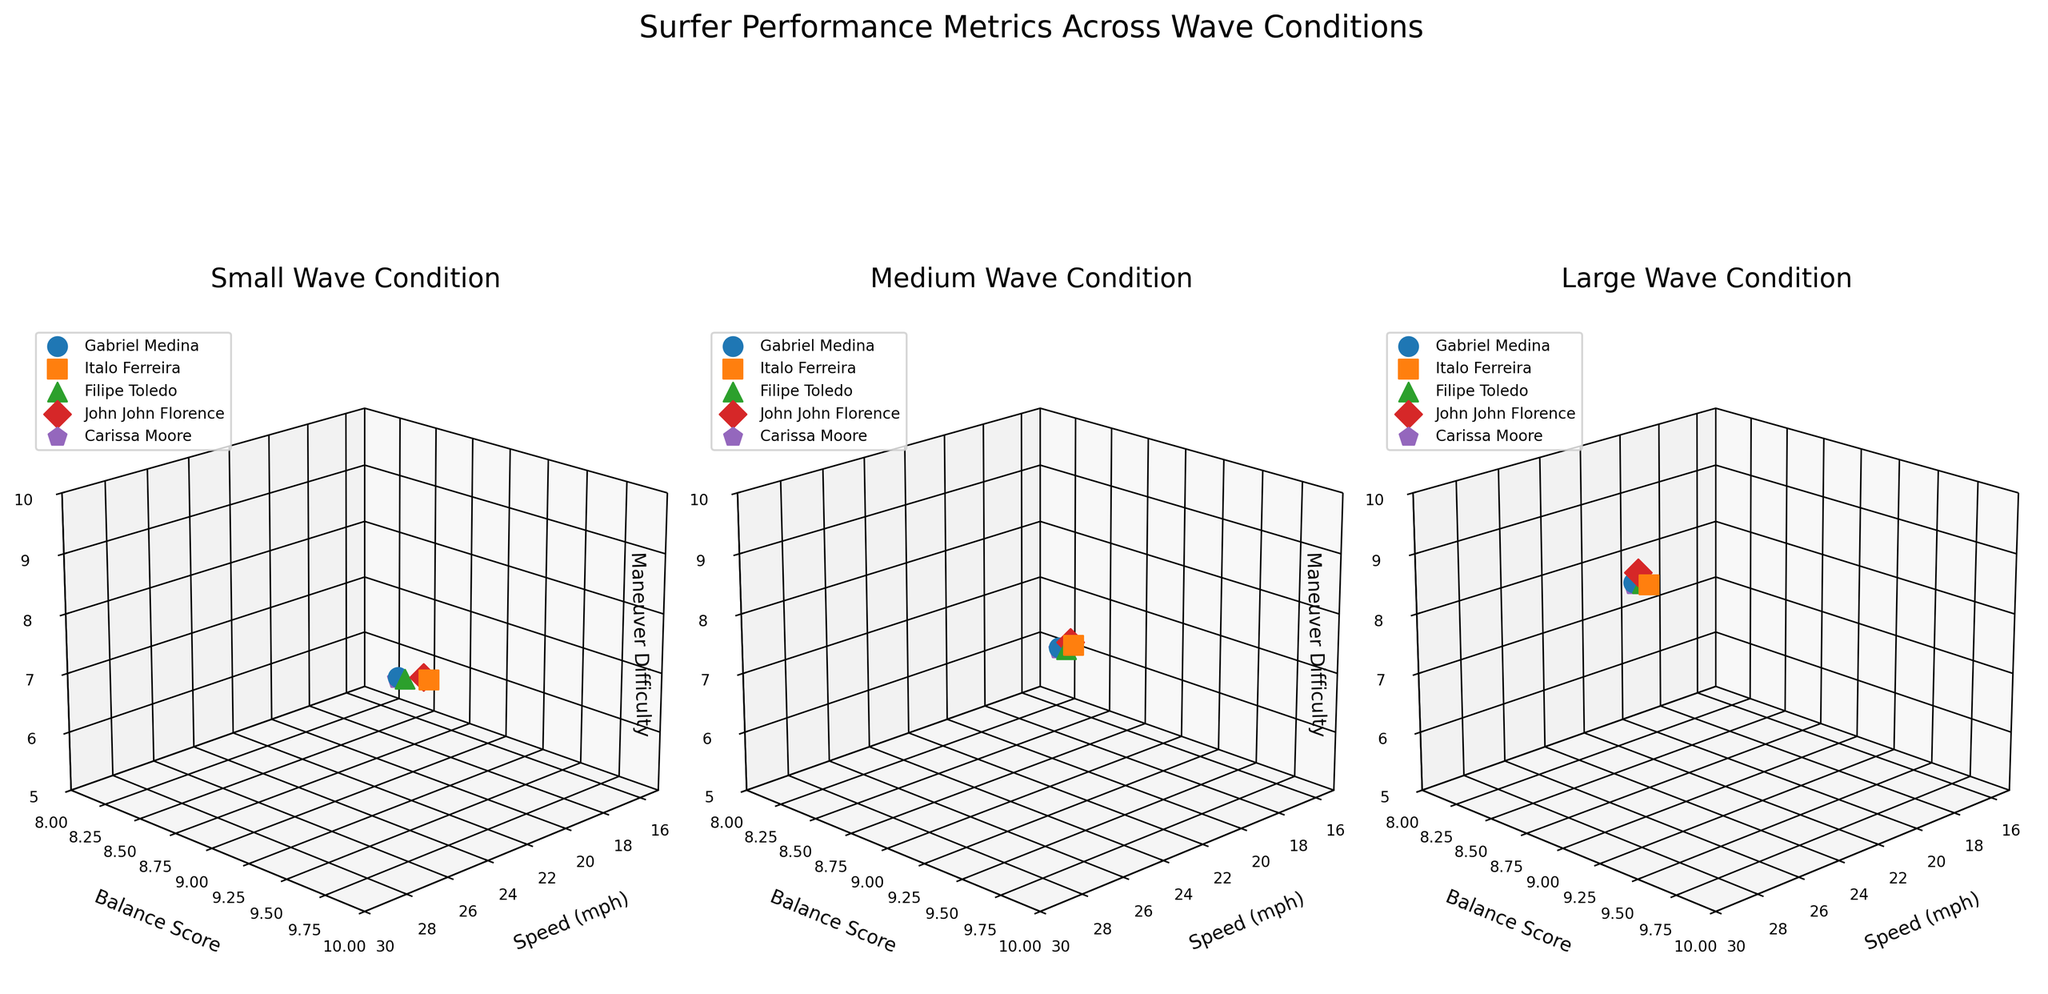How many surfers are plotted in each subplot? Each subplot represents a different wave condition (Small, Medium, Large), and each surfer is marked with a unique marker and color. By counting the different markers and colors in any subplot, we can see there are five surfers plotted in each.
Answer: 5 Which wave condition had the highest maneuver difficulty for Carissa Moore? By looking at the points representing Carissa Moore in the subplots (each subplot corresponds to a wave condition), we can see the highest 'Maneuver Difficulty' score associated with her name. It is highest in the Large wave condition.
Answer: Large Who achieved the highest balance score in Small wave conditions? In the subplot for Small wave conditions, examine the 'Balance Score' axis for the surfer with the highest point on this axis. Italo Ferreira has the highest balance score in this condition.
Answer: Italo Ferreira How does Gabriel Medina's speed change across different wave conditions? Observe Gabriel Medina's points in each subplot (Small, Medium, Large). Read his speeds from the 'Speed (mph)' axis. They increase from Small to Large (18.5, 22.3, and 25.8 respectively).
Answer: Increases Compare the overall balance scores between Medium and Large wave conditions. In the Medium and Large subplots, compare the distribution and values on the 'Balance Score' axis. The scores slightly vary, with Medium scores being slightly higher overall.
Answer: Medium slightly higher What is the range of maneuver difficulty for Italo Ferreira across all wave conditions? Observe Italo Ferreira's points in all three subplots (Small, Medium, Large). Identify the minimum and maximum 'Maneuver Difficulty' scores. They range from 6.5 to 9.0.
Answer: 6.5 to 9.0 Which surfer had the lowest speed in the Medium wave condition? In the Medium wave condition subplot, locate the surfer with the lowest point on the 'Speed (mph)' axis. Carissa Moore has the lowest speed in this condition.
Answer: Carissa Moore Do any surfers have identical balance scores in the Large wave condition? In the Large wave condition subplot, observe the 'Balance Score' axis for any identical scores among the surfers. Gabriel Medina, Filipe Toledo, and John John Florence all have an identical balance score of 9.0.
Answer: Yes What is the average maneuver difficulty for all surfers in the Small wave condition? In the Small wave condition subplot, add up all the 'Maneuver Difficulty' scores (6.2, 6.5, 6.3, 6.4, 6.0), then divide by the number of surfers (5). The result is (6.2 + 6.5 + 6.3 + 6.4 + 6.0) / 5 = 31.4 / 5 = 6.28.
Answer: 6.28 